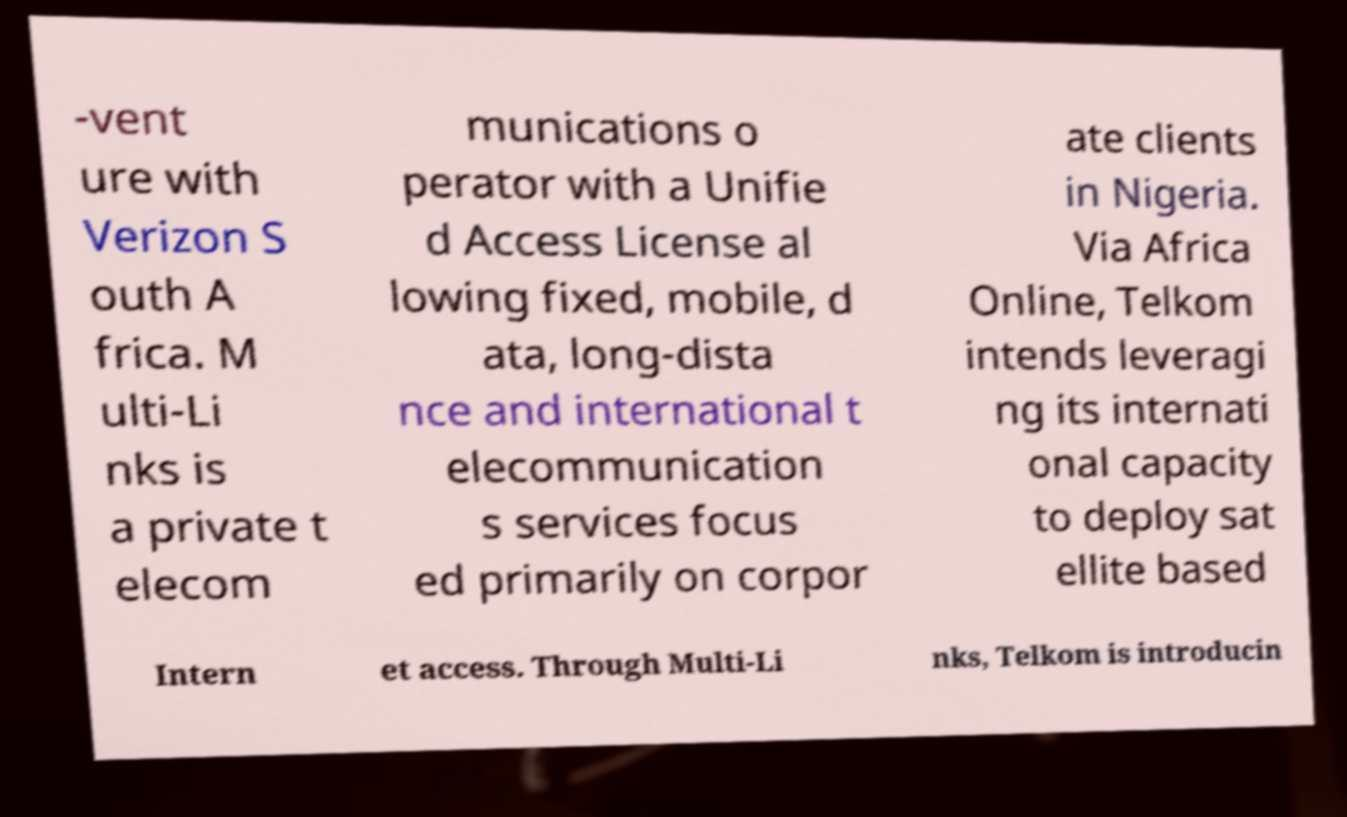Please identify and transcribe the text found in this image. -vent ure with Verizon S outh A frica. M ulti-Li nks is a private t elecom munications o perator with a Unifie d Access License al lowing fixed, mobile, d ata, long-dista nce and international t elecommunication s services focus ed primarily on corpor ate clients in Nigeria. Via Africa Online, Telkom intends leveragi ng its internati onal capacity to deploy sat ellite based Intern et access. Through Multi-Li nks, Telkom is introducin 